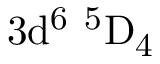Convert formula to latex. <formula><loc_0><loc_0><loc_500><loc_500>3 d ^ { 6 } \ ^ { 5 } D _ { 4 }</formula> 